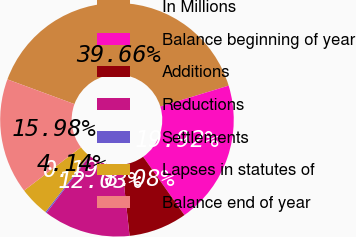Convert chart to OTSL. <chart><loc_0><loc_0><loc_500><loc_500><pie_chart><fcel>In Millions<fcel>Balance beginning of year<fcel>Additions<fcel>Reductions<fcel>Settlements<fcel>Lapses in statutes of<fcel>Balance end of year<nl><fcel>39.66%<fcel>19.92%<fcel>8.08%<fcel>12.03%<fcel>0.19%<fcel>4.14%<fcel>15.98%<nl></chart> 